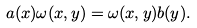<formula> <loc_0><loc_0><loc_500><loc_500>a ( x ) \omega ( x , y ) = \omega ( x , y ) b ( y ) .</formula> 